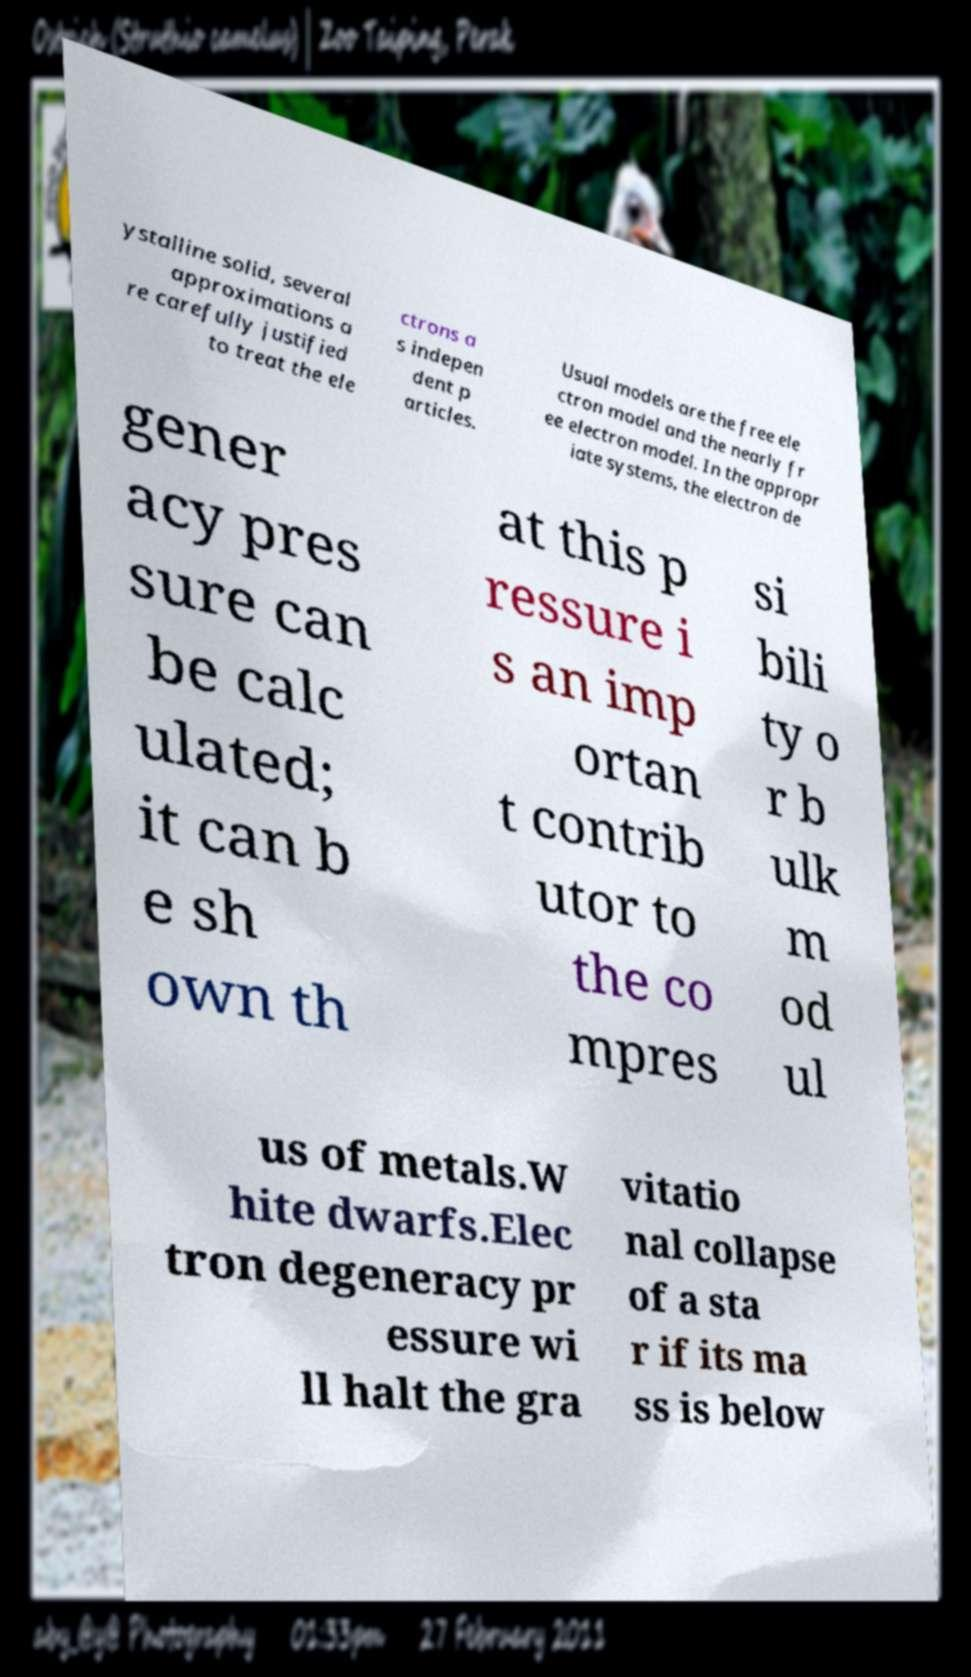For documentation purposes, I need the text within this image transcribed. Could you provide that? ystalline solid, several approximations a re carefully justified to treat the ele ctrons a s indepen dent p articles. Usual models are the free ele ctron model and the nearly fr ee electron model. In the appropr iate systems, the electron de gener acy pres sure can be calc ulated; it can b e sh own th at this p ressure i s an imp ortan t contrib utor to the co mpres si bili ty o r b ulk m od ul us of metals.W hite dwarfs.Elec tron degeneracy pr essure wi ll halt the gra vitatio nal collapse of a sta r if its ma ss is below 